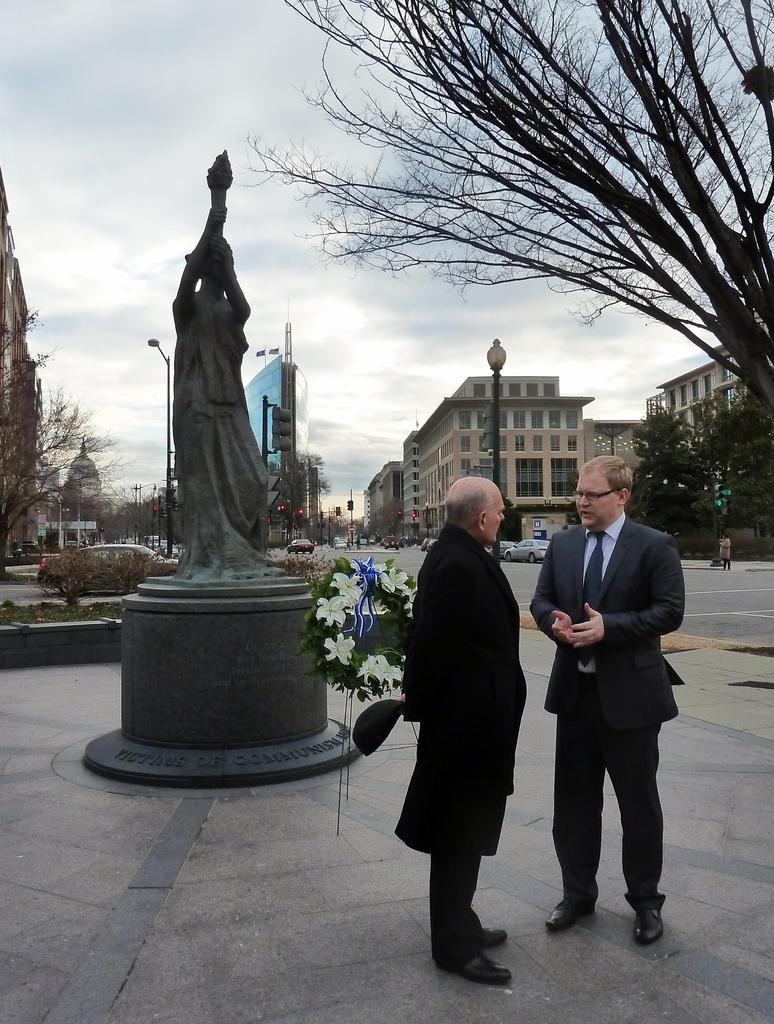In one or two sentences, can you explain what this image depicts? On the right side of the image we can see two people standing. On the left there is a statue. In the background there are poles, buildings, trees, cars and sky. 